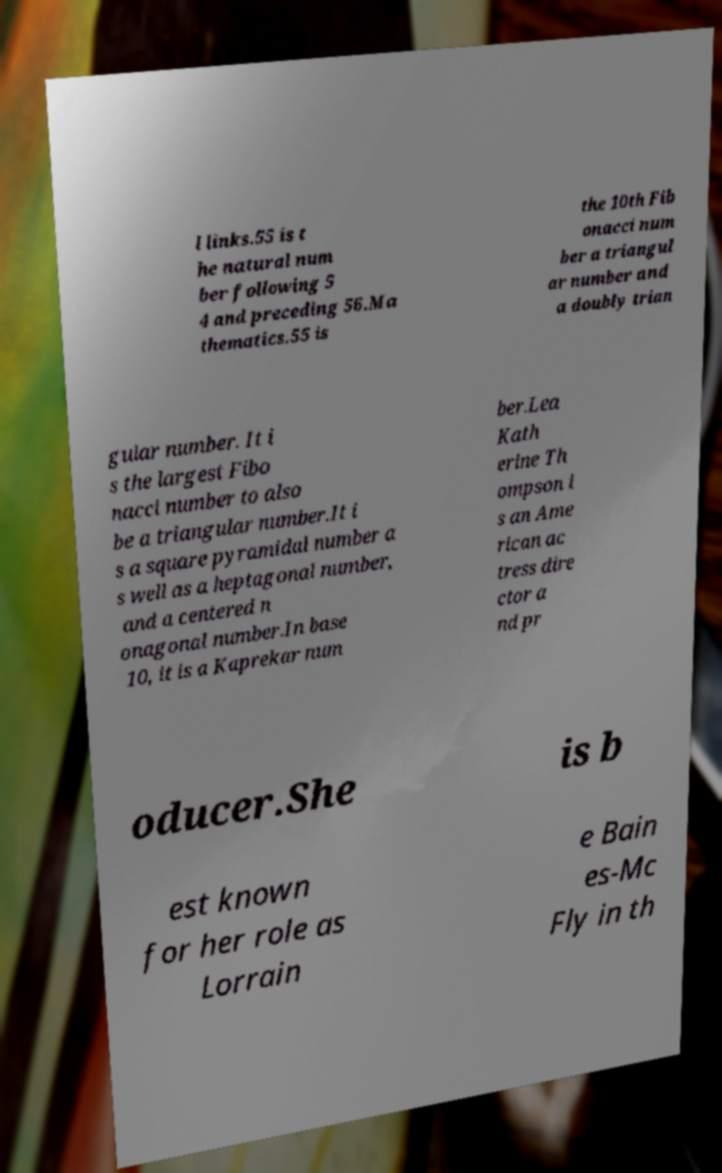Can you read and provide the text displayed in the image?This photo seems to have some interesting text. Can you extract and type it out for me? l links.55 is t he natural num ber following 5 4 and preceding 56.Ma thematics.55 is the 10th Fib onacci num ber a triangul ar number and a doubly trian gular number. It i s the largest Fibo nacci number to also be a triangular number.It i s a square pyramidal number a s well as a heptagonal number, and a centered n onagonal number.In base 10, it is a Kaprekar num ber.Lea Kath erine Th ompson i s an Ame rican ac tress dire ctor a nd pr oducer.She is b est known for her role as Lorrain e Bain es-Mc Fly in th 